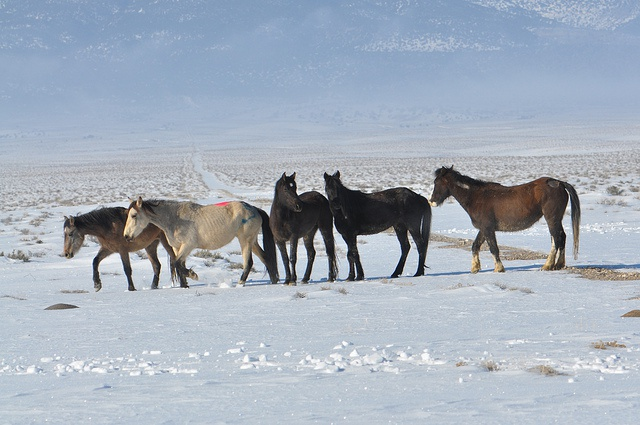Describe the objects in this image and their specific colors. I can see horse in darkgray, black, gray, and maroon tones, horse in darkgray, gray, and black tones, horse in darkgray, black, gray, and navy tones, horse in darkgray, black, gray, and lightgray tones, and horse in darkgray, black, gray, and maroon tones in this image. 